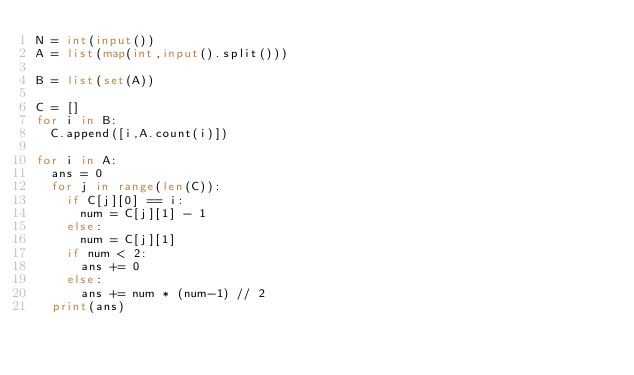Convert code to text. <code><loc_0><loc_0><loc_500><loc_500><_Python_>N = int(input())
A = list(map(int,input().split()))

B = list(set(A))

C = []
for i in B:
  C.append([i,A.count(i)])

for i in A:
  ans = 0
  for j in range(len(C)):
    if C[j][0] == i:
      num = C[j][1] - 1
    else:
      num = C[j][1]
    if num < 2:
      ans += 0
    else:
      ans += num * (num-1) // 2
  print(ans)</code> 